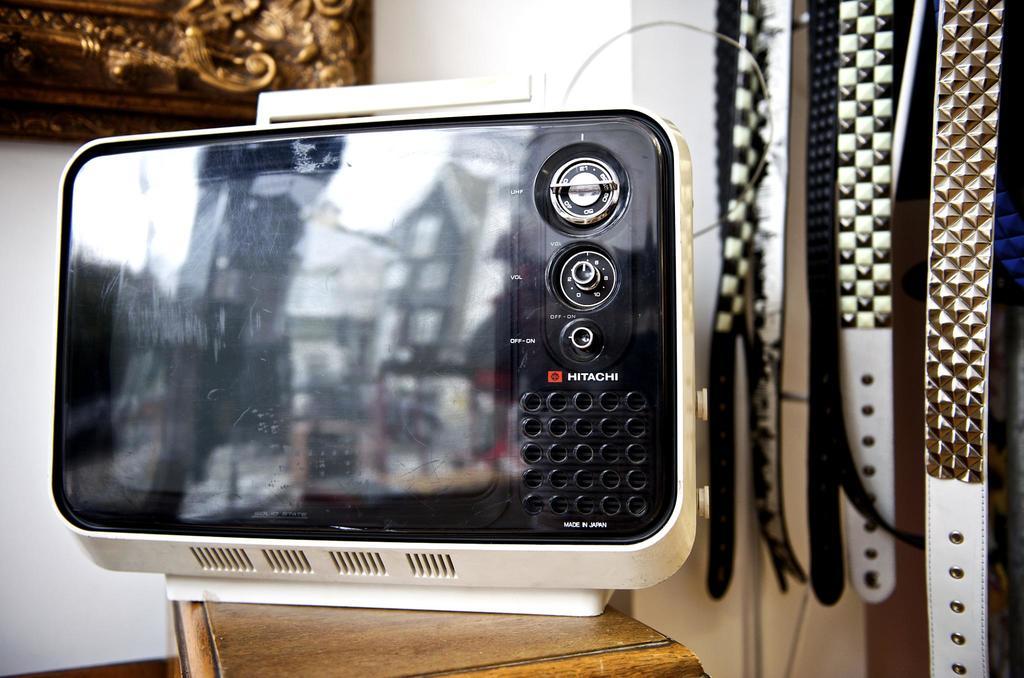What brand of device is this?
Your answer should be compact. Hitachi. Was this made in japan?
Offer a terse response. Yes. 